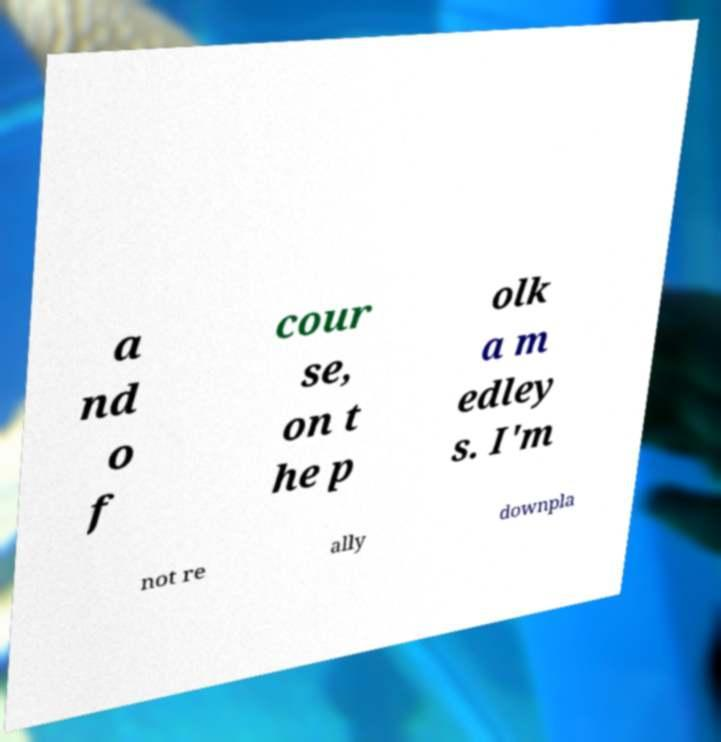There's text embedded in this image that I need extracted. Can you transcribe it verbatim? a nd o f cour se, on t he p olk a m edley s. I'm not re ally downpla 